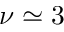<formula> <loc_0><loc_0><loc_500><loc_500>\nu \simeq 3</formula> 